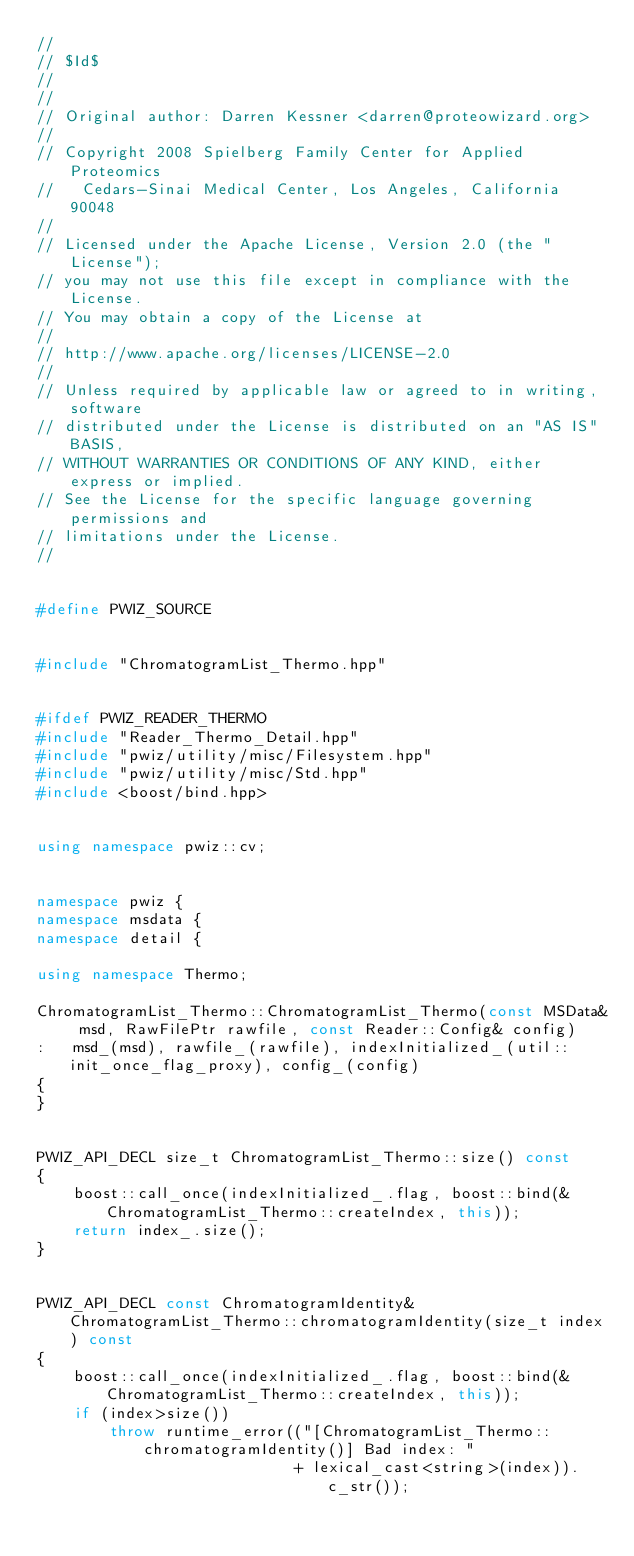Convert code to text. <code><loc_0><loc_0><loc_500><loc_500><_C++_>//
// $Id$
//
//
// Original author: Darren Kessner <darren@proteowizard.org>
//
// Copyright 2008 Spielberg Family Center for Applied Proteomics
//   Cedars-Sinai Medical Center, Los Angeles, California  90048
//
// Licensed under the Apache License, Version 2.0 (the "License"); 
// you may not use this file except in compliance with the License. 
// You may obtain a copy of the License at 
//
// http://www.apache.org/licenses/LICENSE-2.0
//
// Unless required by applicable law or agreed to in writing, software 
// distributed under the License is distributed on an "AS IS" BASIS, 
// WITHOUT WARRANTIES OR CONDITIONS OF ANY KIND, either express or implied. 
// See the License for the specific language governing permissions and 
// limitations under the License.
//


#define PWIZ_SOURCE


#include "ChromatogramList_Thermo.hpp"


#ifdef PWIZ_READER_THERMO
#include "Reader_Thermo_Detail.hpp"
#include "pwiz/utility/misc/Filesystem.hpp"
#include "pwiz/utility/misc/Std.hpp"
#include <boost/bind.hpp>


using namespace pwiz::cv;


namespace pwiz {
namespace msdata {
namespace detail {

using namespace Thermo;

ChromatogramList_Thermo::ChromatogramList_Thermo(const MSData& msd, RawFilePtr rawfile, const Reader::Config& config)
:   msd_(msd), rawfile_(rawfile), indexInitialized_(util::init_once_flag_proxy), config_(config)
{
}


PWIZ_API_DECL size_t ChromatogramList_Thermo::size() const
{
    boost::call_once(indexInitialized_.flag, boost::bind(&ChromatogramList_Thermo::createIndex, this));
    return index_.size();
}


PWIZ_API_DECL const ChromatogramIdentity& ChromatogramList_Thermo::chromatogramIdentity(size_t index) const
{
    boost::call_once(indexInitialized_.flag, boost::bind(&ChromatogramList_Thermo::createIndex, this));
    if (index>size())
        throw runtime_error(("[ChromatogramList_Thermo::chromatogramIdentity()] Bad index: " 
                            + lexical_cast<string>(index)).c_str());</code> 